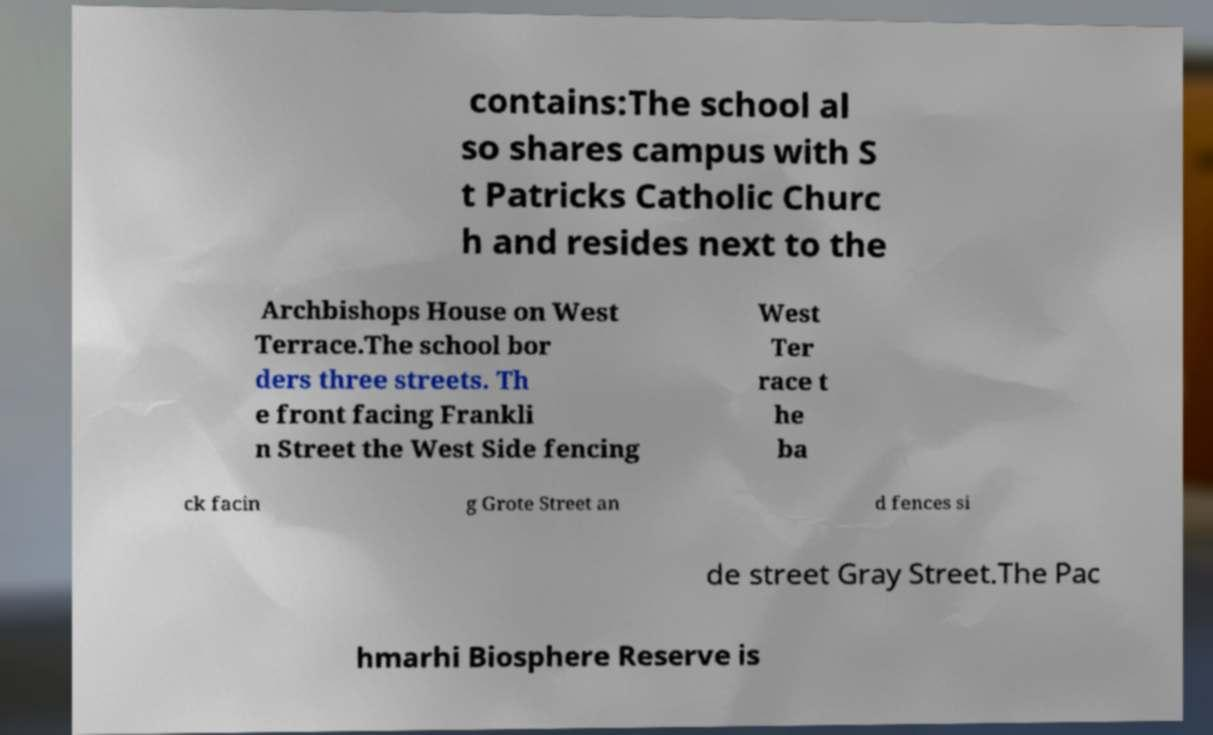Please read and relay the text visible in this image. What does it say? contains:The school al so shares campus with S t Patricks Catholic Churc h and resides next to the Archbishops House on West Terrace.The school bor ders three streets. Th e front facing Frankli n Street the West Side fencing West Ter race t he ba ck facin g Grote Street an d fences si de street Gray Street.The Pac hmarhi Biosphere Reserve is 